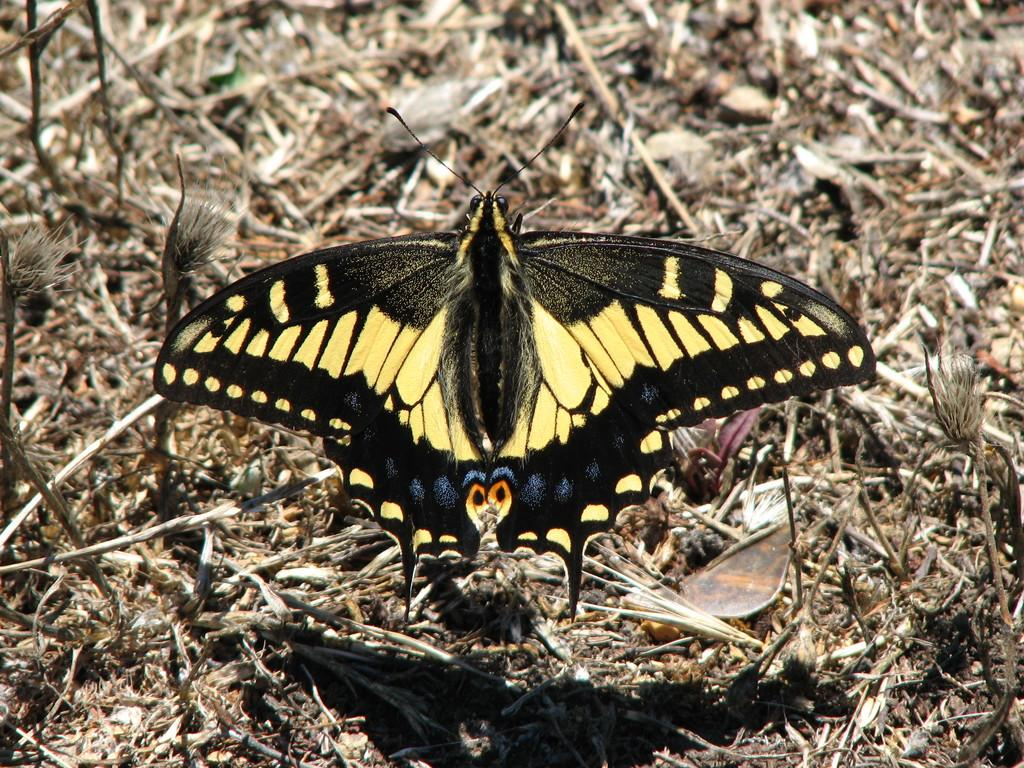What is the main subject of the image? There is a butterfly in the image. Where is the butterfly located? The butterfly is on the ground. What can be seen in the background of the image? There are small sticks visible in the background of the image. What type of advertisement can be seen on the butterfly's wings in the image? There is no advertisement present on the butterfly's wings in the image. What is the butterfly having for lunch in the image? Butterflies do not eat lunch, as they primarily consume nectar from flowers. 